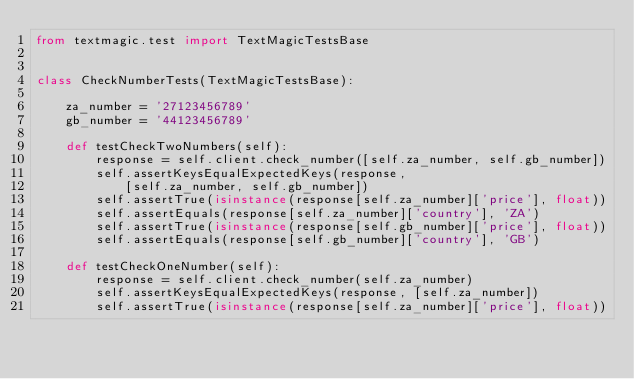<code> <loc_0><loc_0><loc_500><loc_500><_Python_>from textmagic.test import TextMagicTestsBase


class CheckNumberTests(TextMagicTestsBase):

    za_number = '27123456789'
    gb_number = '44123456789'

    def testCheckTwoNumbers(self):
        response = self.client.check_number([self.za_number, self.gb_number])
        self.assertKeysEqualExpectedKeys(response,
            [self.za_number, self.gb_number])
        self.assertTrue(isinstance(response[self.za_number]['price'], float))
        self.assertEquals(response[self.za_number]['country'], 'ZA')
        self.assertTrue(isinstance(response[self.gb_number]['price'], float))
        self.assertEquals(response[self.gb_number]['country'], 'GB')

    def testCheckOneNumber(self):
        response = self.client.check_number(self.za_number)
        self.assertKeysEqualExpectedKeys(response, [self.za_number])
        self.assertTrue(isinstance(response[self.za_number]['price'], float))</code> 